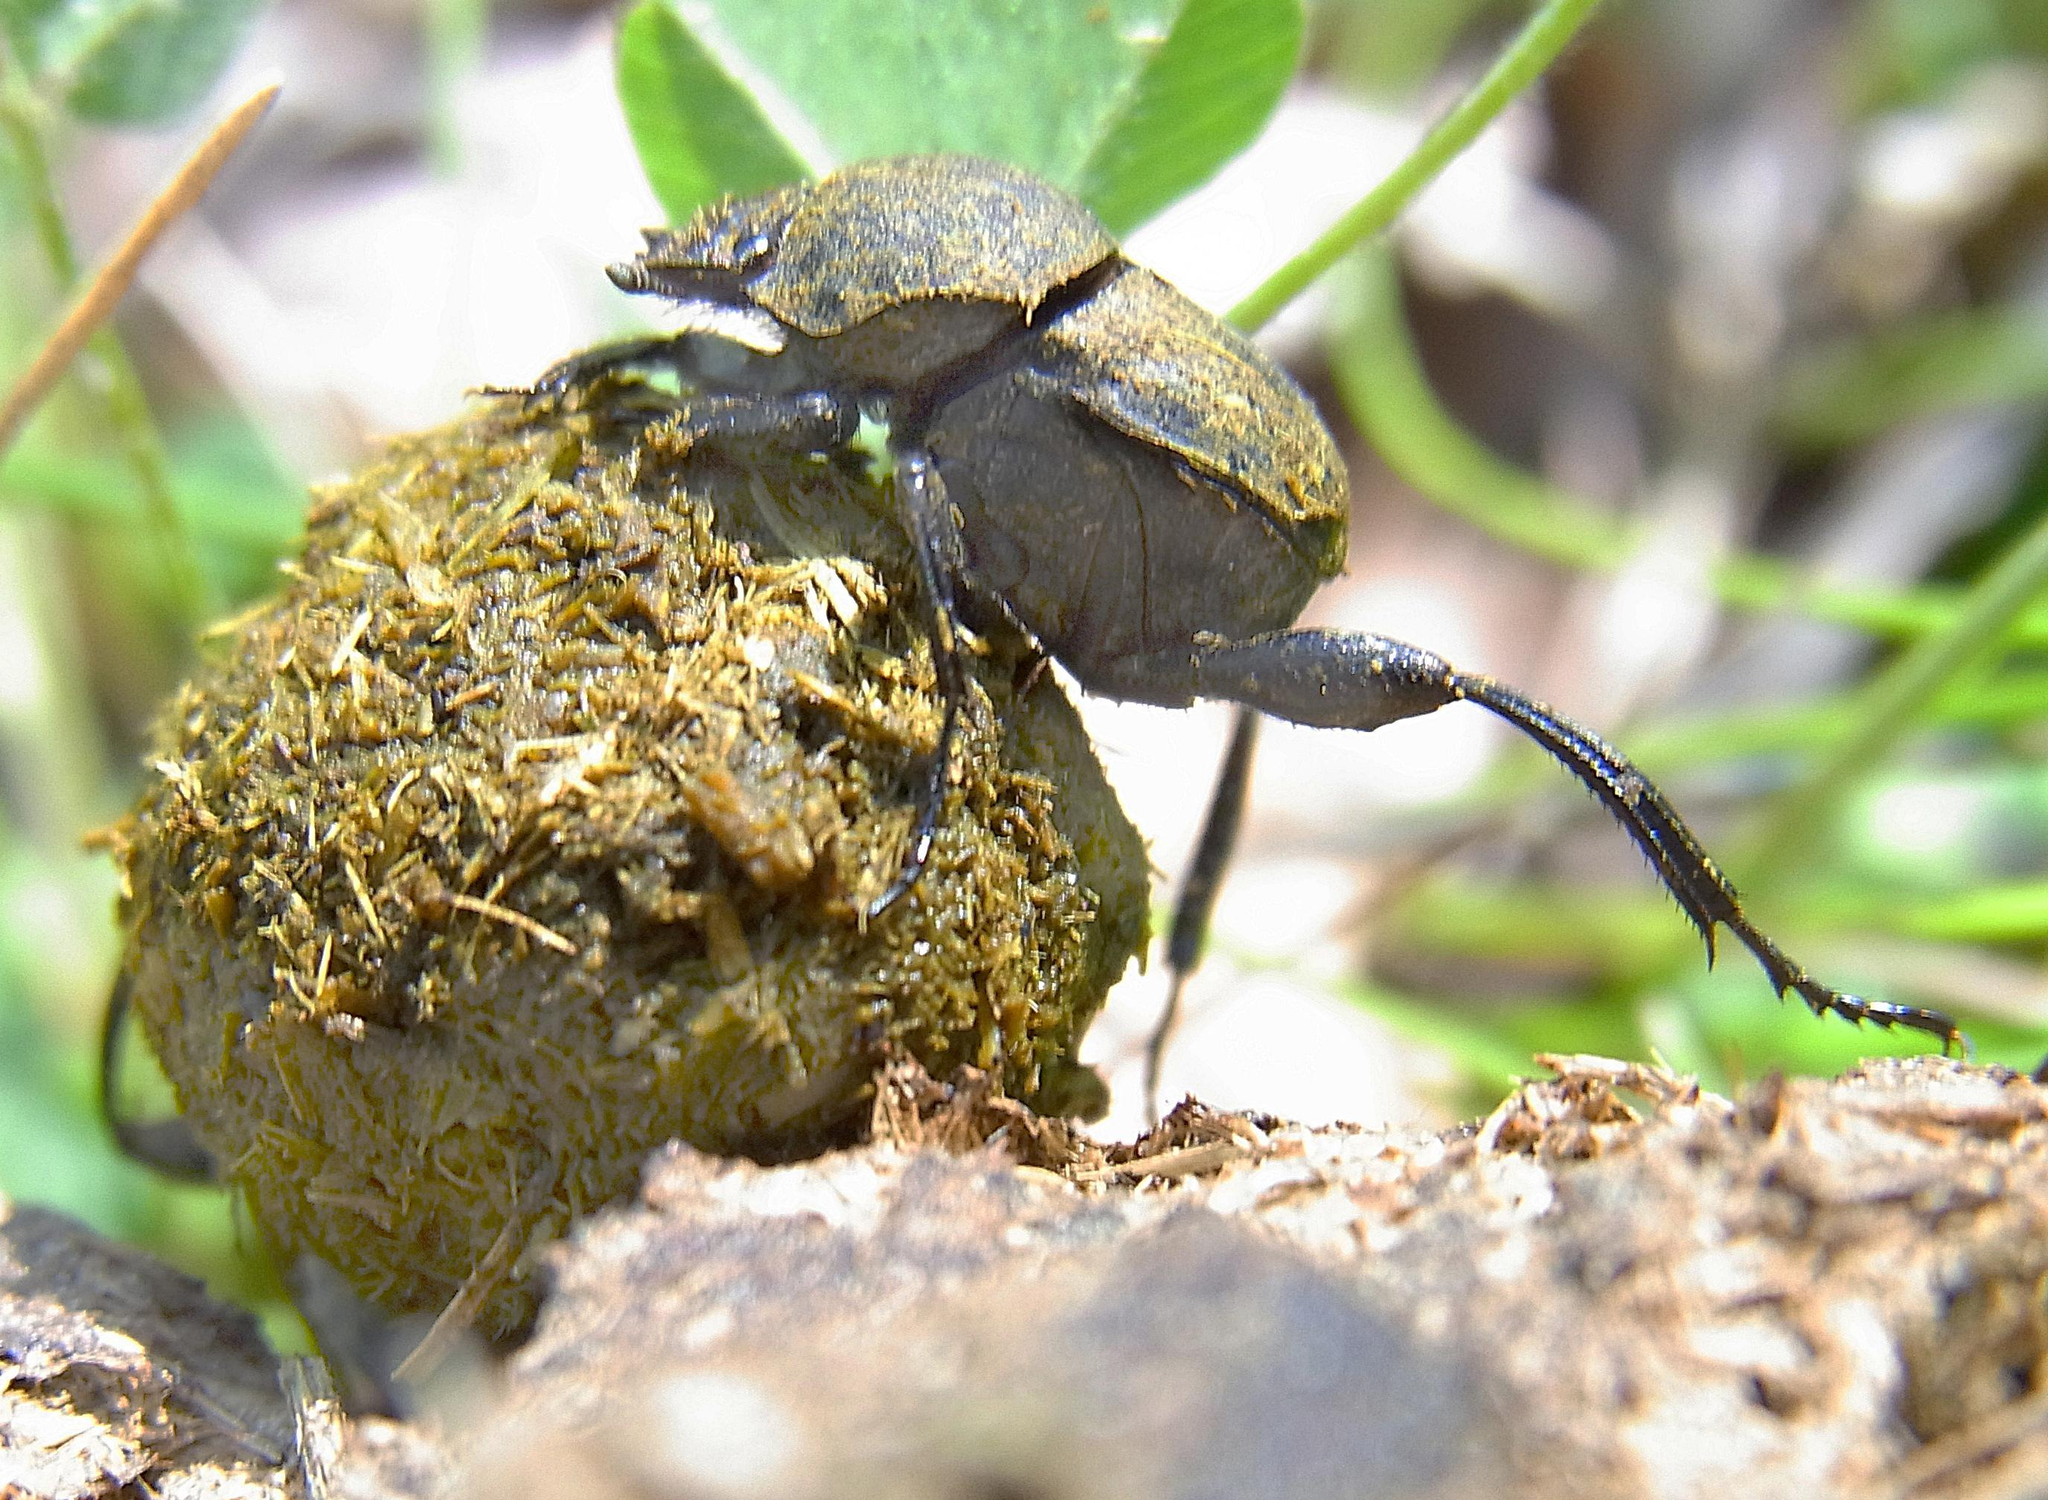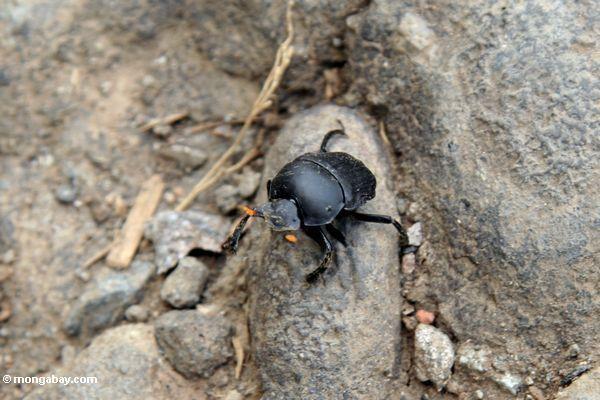The first image is the image on the left, the second image is the image on the right. For the images shown, is this caption "The beetle in the image on the left is on the right of the ball of dirt." true? Answer yes or no. Yes. The first image is the image on the left, the second image is the image on the right. For the images displayed, is the sentence "An image shows a beetle with its hind legs on a dung ball and its head facing the ground." factually correct? Answer yes or no. No. 